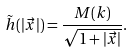<formula> <loc_0><loc_0><loc_500><loc_500>\tilde { h } ( | \vec { x } | ) = \frac { M ( k ) } { \sqrt { 1 + | \vec { x } | } } .</formula> 